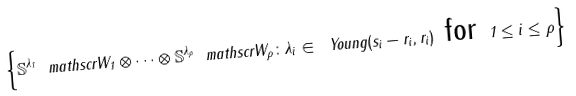<formula> <loc_0><loc_0><loc_500><loc_500>\left \{ \mathbb { S } ^ { \lambda _ { 1 } } \ m a t h s c r { W } _ { 1 } \otimes \dots \otimes \mathbb { S } ^ { \lambda _ { \rho } } \ m a t h s c r { W } _ { \rho } \colon \lambda _ { i } \in \ Y o u n g ( s _ { i } - r _ { i } , r _ { i } ) \text { for } 1 \leq i \leq \rho \right \}</formula> 